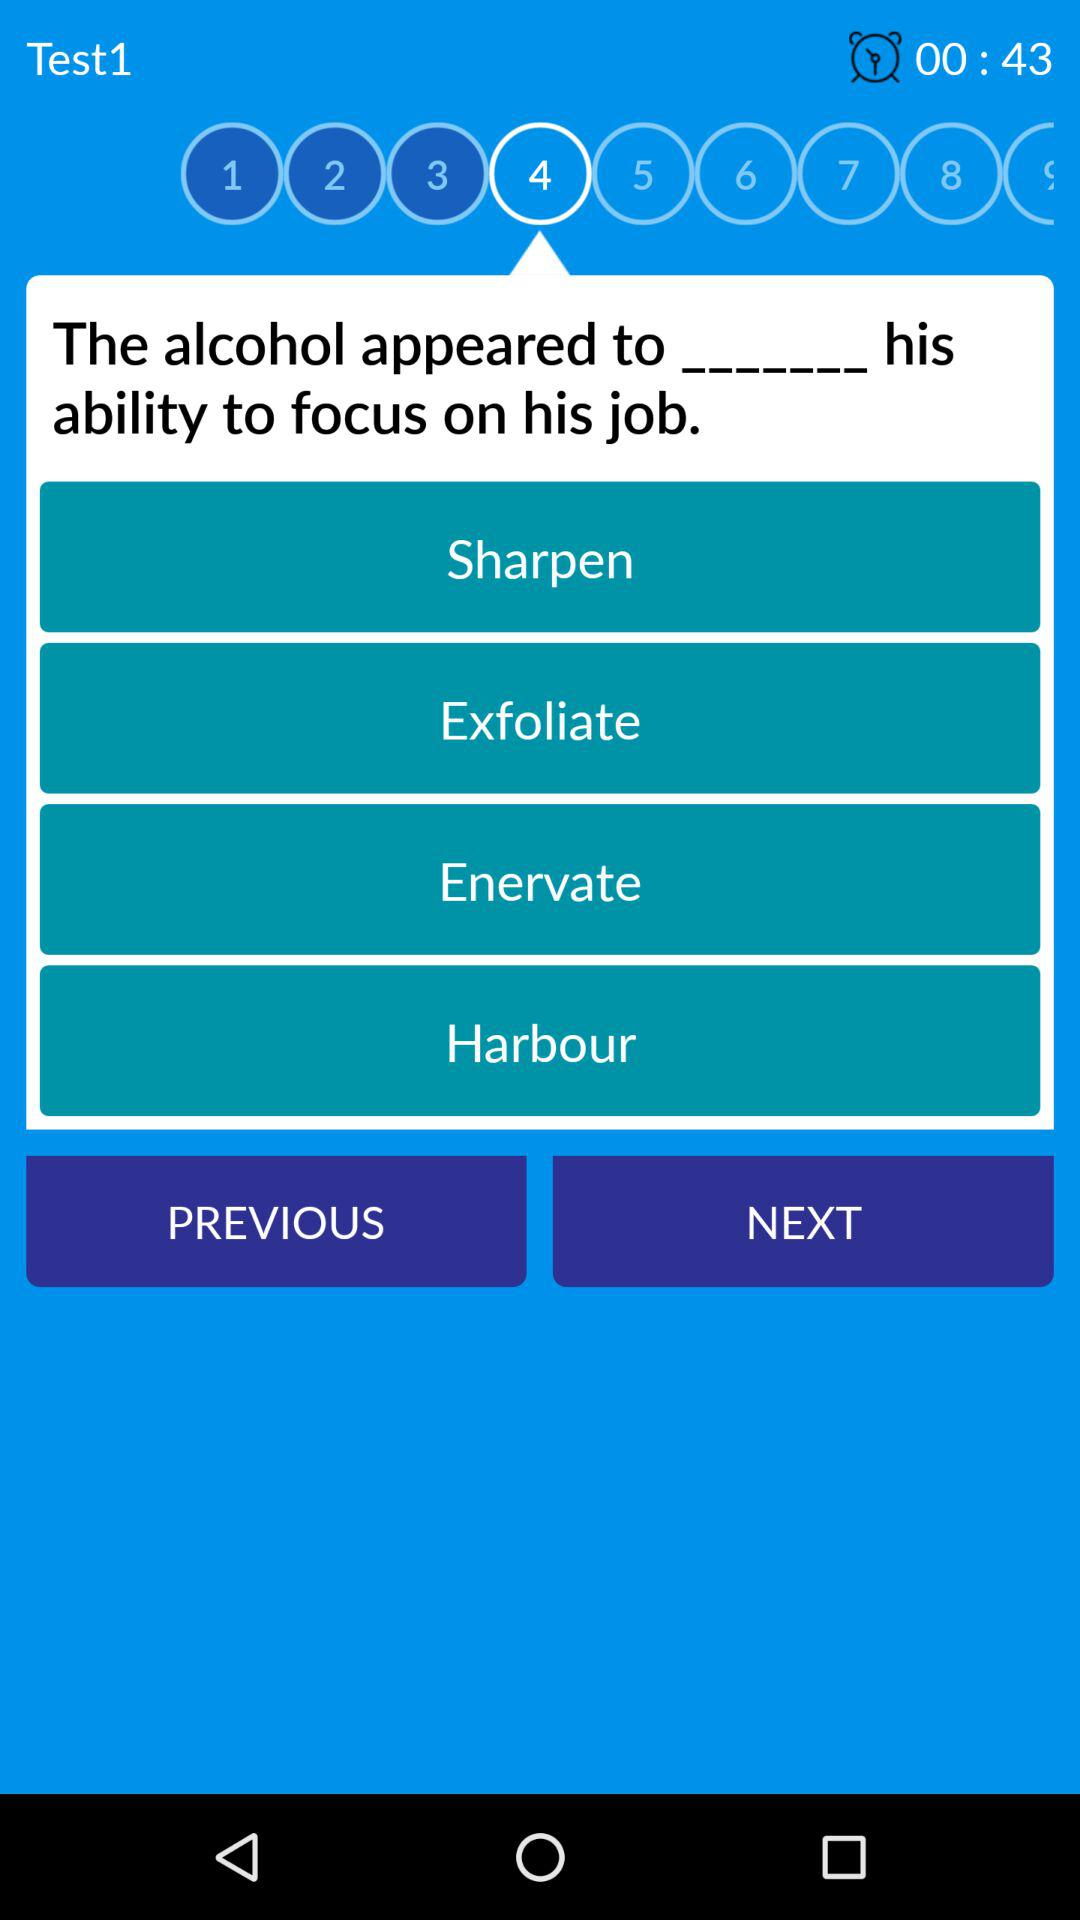What is the time limit for answering the question? The time limit is 43 seconds. 